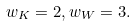Convert formula to latex. <formula><loc_0><loc_0><loc_500><loc_500>w _ { K } = 2 , w _ { W } = 3 .</formula> 